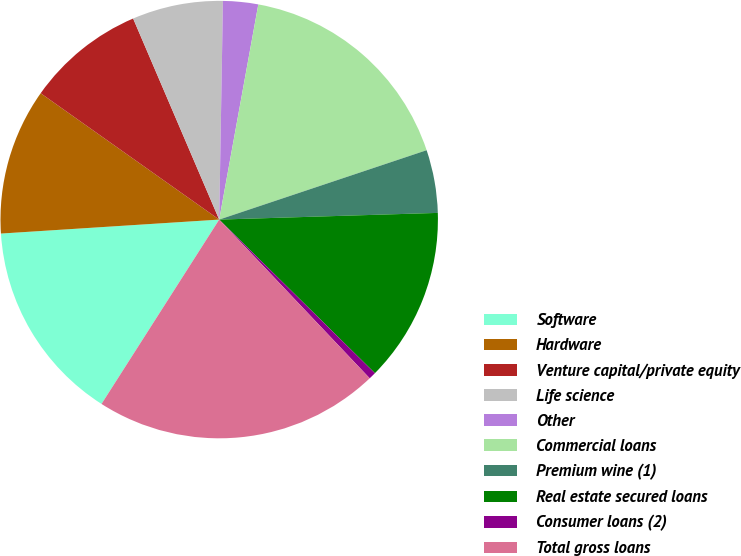Convert chart. <chart><loc_0><loc_0><loc_500><loc_500><pie_chart><fcel>Software<fcel>Hardware<fcel>Venture capital/private equity<fcel>Life science<fcel>Other<fcel>Commercial loans<fcel>Premium wine (1)<fcel>Real estate secured loans<fcel>Consumer loans (2)<fcel>Total gross loans<nl><fcel>14.94%<fcel>10.82%<fcel>8.76%<fcel>6.71%<fcel>2.59%<fcel>17.0%<fcel>4.65%<fcel>12.88%<fcel>0.53%<fcel>21.12%<nl></chart> 